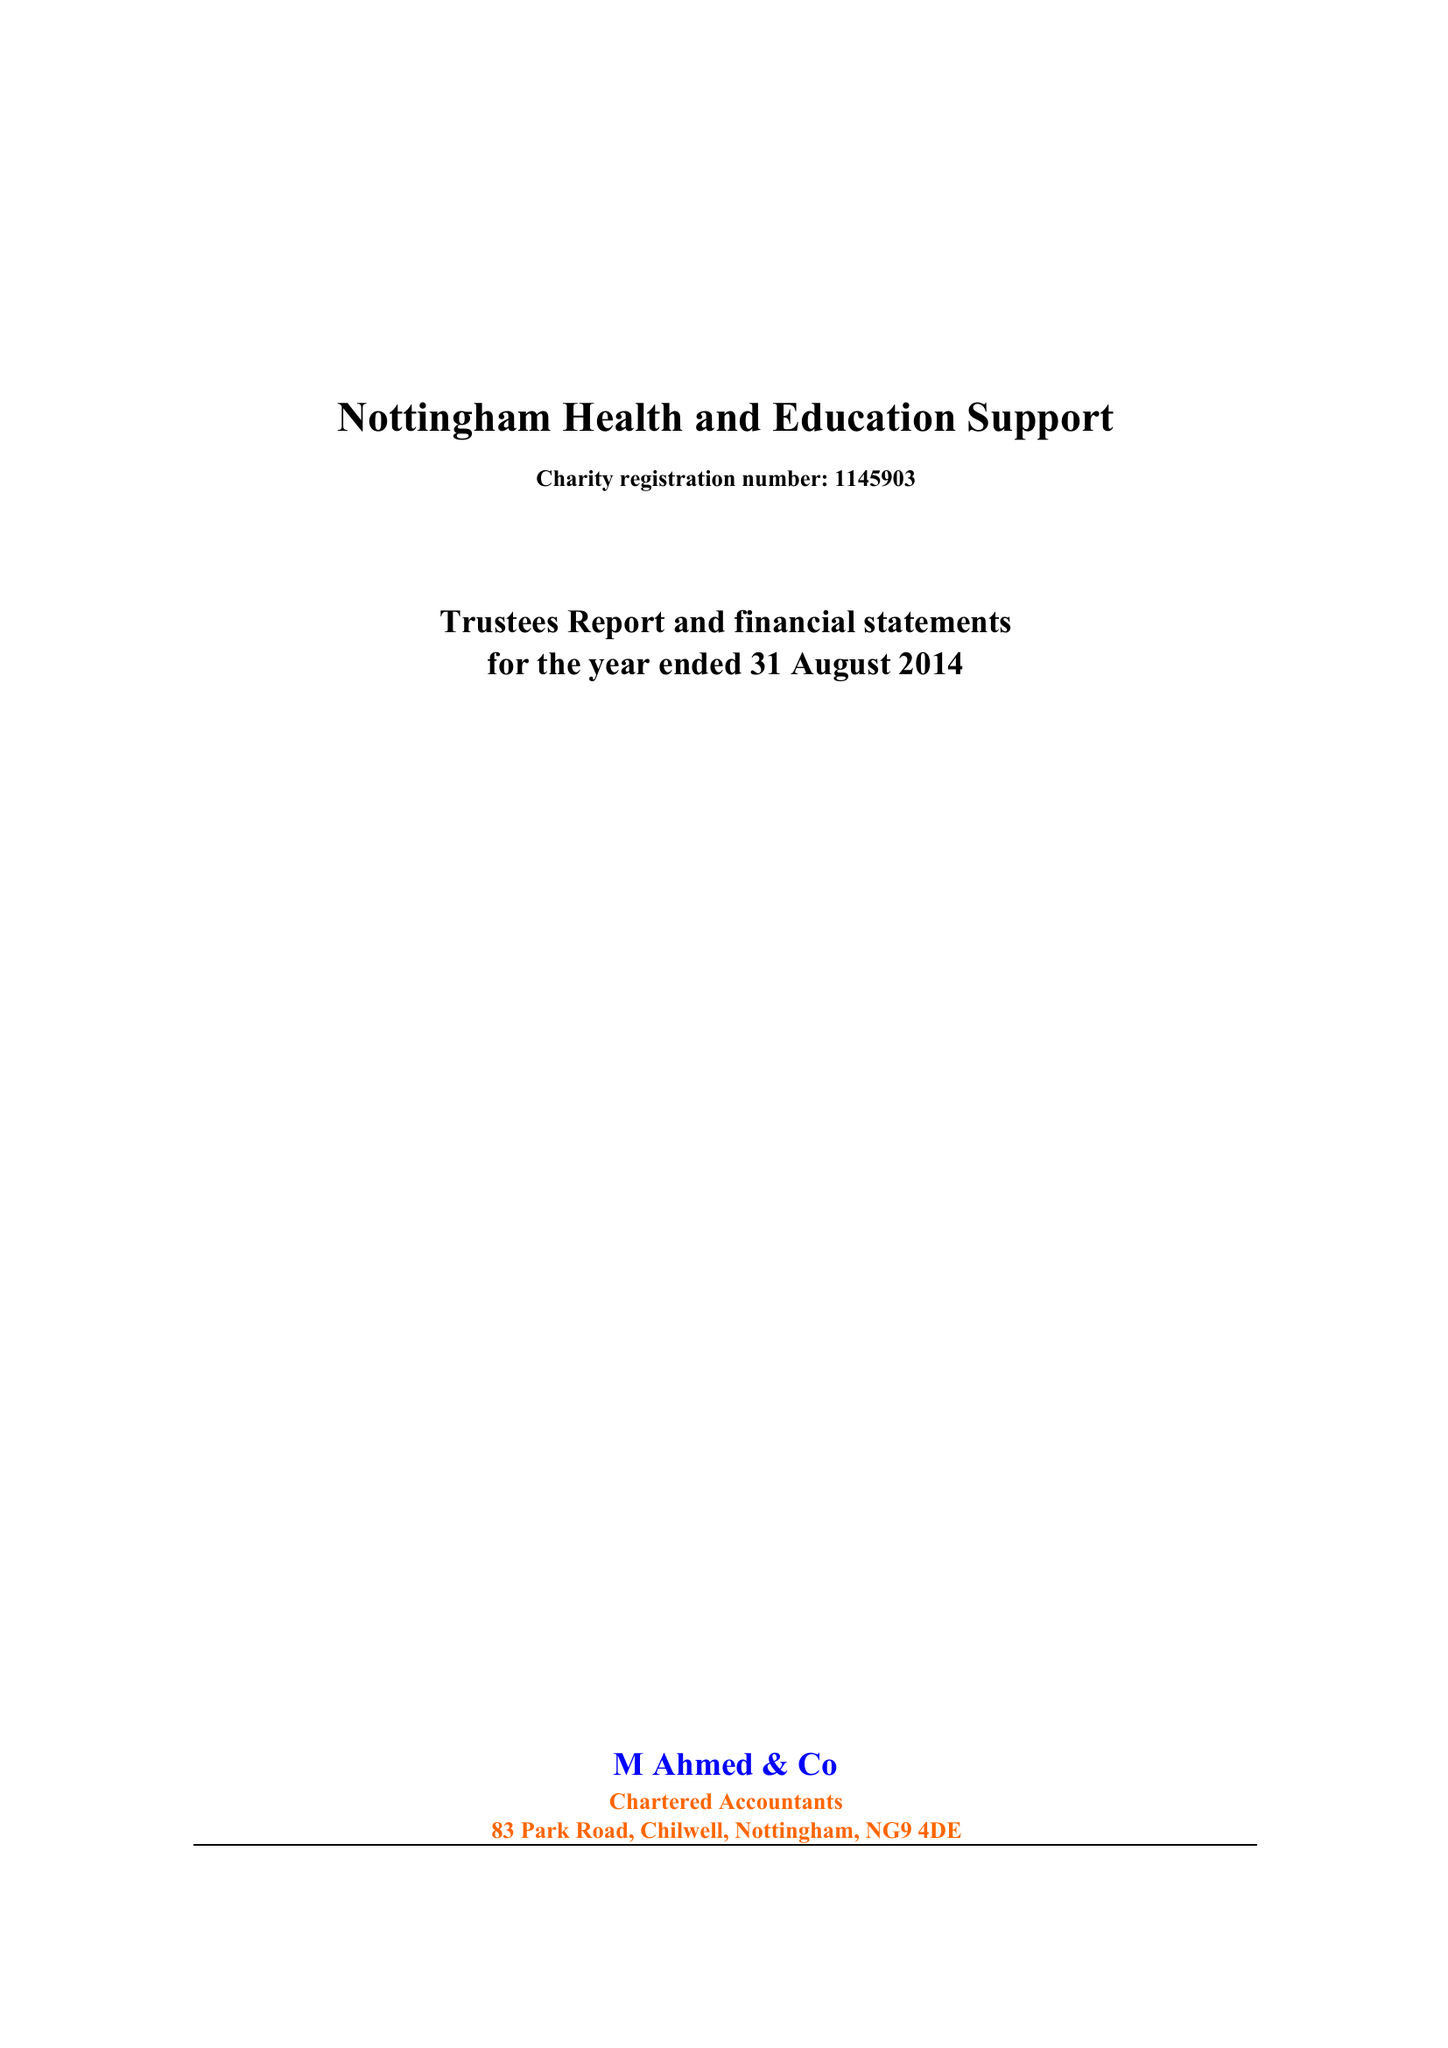What is the value for the income_annually_in_british_pounds?
Answer the question using a single word or phrase. 85525.00 